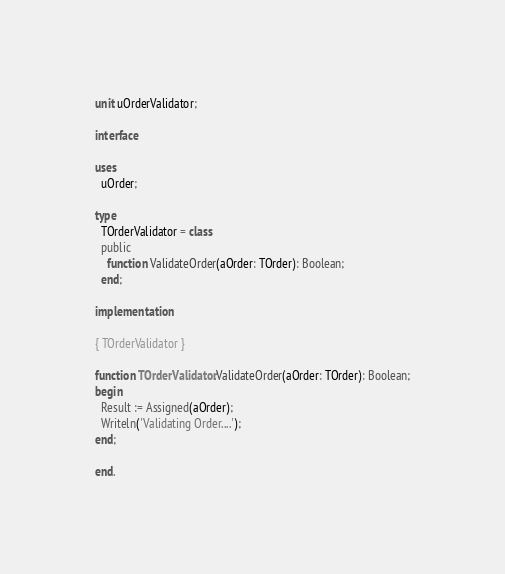Convert code to text. <code><loc_0><loc_0><loc_500><loc_500><_Pascal_>unit uOrderValidator;

interface

uses
  uOrder;

type
  TOrderValidator = class
  public
    function ValidateOrder(aOrder: TOrder): Boolean;
  end;

implementation

{ TOrderValidator }

function TOrderValidator.ValidateOrder(aOrder: TOrder): Boolean;
begin
  Result := Assigned(aOrder);
  Writeln('Validating Order....');
end;

end.
</code> 